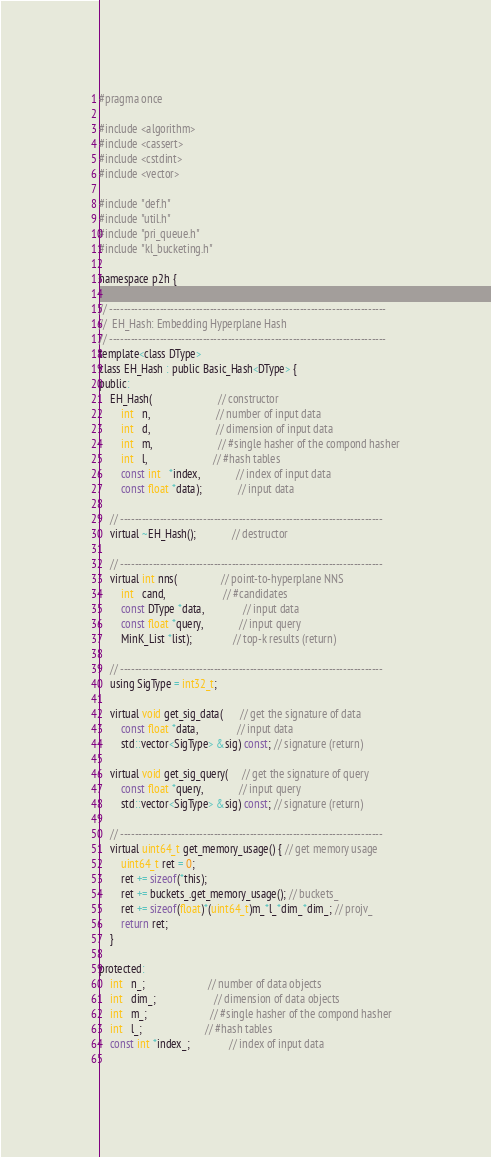Convert code to text. <code><loc_0><loc_0><loc_500><loc_500><_C_>#pragma once

#include <algorithm>
#include <cassert>
#include <cstdint>
#include <vector>

#include "def.h"
#include "util.h"
#include "pri_queue.h"
#include "kl_bucketing.h"

namespace p2h {

// -----------------------------------------------------------------------------
//  EH_Hash: Embedding Hyperplane Hash
// -----------------------------------------------------------------------------
template<class DType>
class EH_Hash : public Basic_Hash<DType> {
public:
    EH_Hash(                        // constructor
        int   n,                        // number of input data
        int   d,                        // dimension of input data
        int   m,                        // #single hasher of the compond hasher
        int   l,                        // #hash tables
        const int   *index,             // index of input data 
        const float *data);             // input data

    // -------------------------------------------------------------------------
    virtual ~EH_Hash();             // destructor

    // -------------------------------------------------------------------------
    virtual int nns(                // point-to-hyperplane NNS
        int   cand,                     // #candidates
        const DType *data,              // input data
        const float *query,             // input query
        MinK_List *list);               // top-k results (return)

    // -------------------------------------------------------------------------
    using SigType = int32_t;

    virtual void get_sig_data(      // get the signature of data
        const float *data,              // input data
        std::vector<SigType> &sig) const; // signature (return)
    
    virtual void get_sig_query(     // get the signature of query
        const float *query,             // input query 
        std::vector<SigType> &sig) const; // signature (return)

    // -------------------------------------------------------------------------
    virtual uint64_t get_memory_usage() { // get memory usage
        uint64_t ret = 0;
        ret += sizeof(*this);
        ret += buckets_.get_memory_usage(); // buckets_
        ret += sizeof(float)*(uint64_t)m_*l_*dim_*dim_; // projv_
        return ret;
    }

protected:
    int   n_;                       // number of data objects
    int   dim_;                     // dimension of data objects
    int   m_;                       // #single hasher of the compond hasher
    int   l_;                       // #hash tables
    const int *index_;              // index of input data
    </code> 